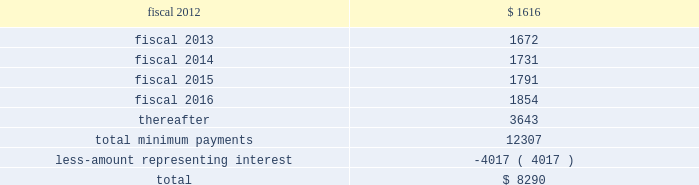Table of contents finance lease obligations the company has a non-cancelable lease agreement for a building with approximately 164000 square feet located in alajuela , costa rica , to be used as a manufacturing and office facility .
The company was responsible for a significant portion of the construction costs , and in accordance with asc 840 , leases , subsection 40-15-5 , the company was deemed to be the owner of the building during the construction period .
The building was completed in fiscal 2008 , and the company has recorded the fair market value of the building and land of $ 15.1 million within property and equipment on its consolidated balance sheets .
At september 24 , 2011 , the company has recorded $ 1.6 million in accrued expenses and $ 16.9 million in other long-term liabilities related to this obligation in the consolidated balance sheet .
The term of the lease , which commenced in may 2008 , is for a period of approximately ten years with the option to extend for two consecutive 5-year terms .
At the completion of the construction period , the company reviewed the lease for potential sale-leaseback treatment in accordance with asc 840 , subsection 40 , sale-leaseback transactions .
Based on its analysis , the company determined that the lease did not qualify for sale-leaseback treatment .
Therefore , the building , leasehold improvements and associated liabilities remain on the company 2019s financial statements throughout the lease term , and the building and leasehold improvements are being depreciated on a straight line basis over their estimated useful lives of 35 years .
Future minimum lease payments , including principal and interest , under this lease were as follows at september 24 , 2011: .
The company also has to a non-cancelable lease agreement for a building with approximately 146000 square feet located in marlborough , massachusetts , to be principally used as an additional manufacturing facility .
As part of the lease agreement , the lessor agreed to allow the company to make significant renovations to the facility to prepare the facility for the company 2019s manufacturing needs .
The company was responsible for a significant amount of the construction costs and therefore in accordance with asc 840-40-15-5 was deemed to be the owner of the building during the construction period .
The $ 13.2 million fair market value of the facility is included within property and equipment on the consolidated balance sheet .
At september 24 , 2011 , the company has recorded $ 1.0 million in accrued expenses and $ 15.9 million in other long-term liabilities related to this obligation in the consolidated balance sheet .
The term of the lease is for a period of approximately 12 years commencing on november 14 , 2006 with the option to extend for two consecutive 5-year terms .
Based on its asc 840-40 analysis , the company determined that the lease did not qualify for sale-leaseback treatment .
Therefore , the improvements and associated liabilities will remain on the company 2019s financial statements throughout the lease term , and the leasehold improvements are being depreciated on a straight line basis over their estimated useful lives of up to 35 years .
Source : hologic inc , 10-k , november 23 , 2011 powered by morningstar ae document research 2120 the information contained herein may not be copied , adapted or distributed and is not warranted to be accurate , complete or timely .
The user assumes all risks for any damages or losses arising from any use of this information , except to the extent such damages or losses cannot be limited or excluded by applicable law .
Past financial performance is no guarantee of future results. .
What portion of the total future minimum lease payments , including interest is due within the next 12 months? 
Computations: (1616 / 12307)
Answer: 0.13131. 